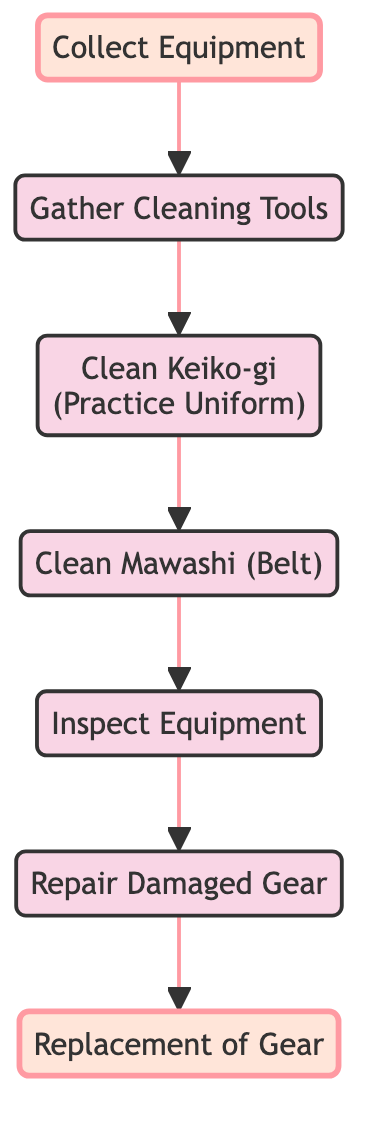What is the first step in the maintenance process? The first step in the flowchart is to "Collect Equipment." This is the starting point and feeds into the subsequent steps for cleaning and maintenance.
Answer: Collect Equipment How many main steps are involved in maintaining equipment? By counting the steps listed in the flowchart, there are a total of 7 main steps involved in the maintenance process, from collecting equipment to replacing gear.
Answer: 7 What follows after "Gather Cleaning Tools"? Following "Gather Cleaning Tools," the next step is "Clean Keiko-gi (Practice Uniform)," indicating the order of operations in the cleaning process.
Answer: Clean Keiko-gi (Practice Uniform) What is the last step after the inspection? The last step after the "Inspect Equipment" is "Repair Damaged Gear," which indicates a progression from inspection to the necessary repairs.
Answer: Repair Damaged Gear What are the two highlighted steps in the flowchart? The two highlighted steps are "Collect Equipment" and "Replacement of Gear," which signify critical points in the maintenance process that stand out from the others.
Answer: Collect Equipment, Replacement of Gear Which step comes directly before "Replacement of Gear"? The step that comes directly before "Replacement of Gear" is "Repair Damaged Gear," indicating a sequence where any repairs needed are addressed prior to replacement.
Answer: Repair Damaged Gear What is the purpose of the "Inspect Equipment" step? The step "Inspect Equipment" serves the purpose of thoroughly checking all pieces of equipment for any wear and tear, which allows for identifying necessary repairs or replacements.
Answer: Thoroughly check for wear and tear How many cleaning tasks are mentioned in the flowchart? The flowchart mentions three cleaning tasks: cleaning the mawashi (belt), cleaning the keiko-gi (practice uniform), and gathering cleaning tools.
Answer: 3 What step precedes the "Clean Mawashi (Belt)"? Before "Clean Mawashi (Belt)," the flowchart shows "Clean Keiko-gi (Practice Uniform)," indicating the order of the cleaning procedures.
Answer: Clean Keiko-gi (Practice Uniform) 